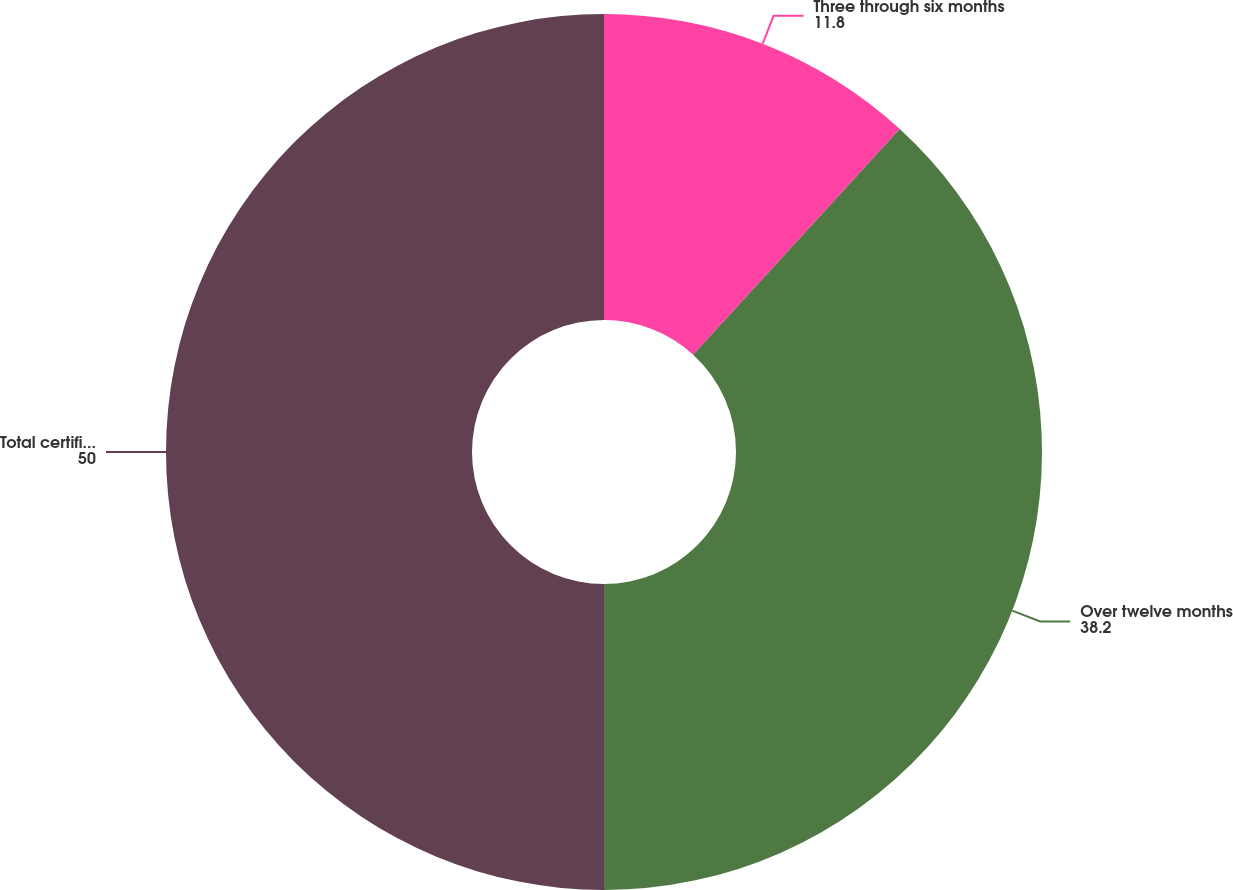<chart> <loc_0><loc_0><loc_500><loc_500><pie_chart><fcel>Three through six months<fcel>Over twelve months<fcel>Total certificates of deposit<nl><fcel>11.8%<fcel>38.2%<fcel>50.0%<nl></chart> 